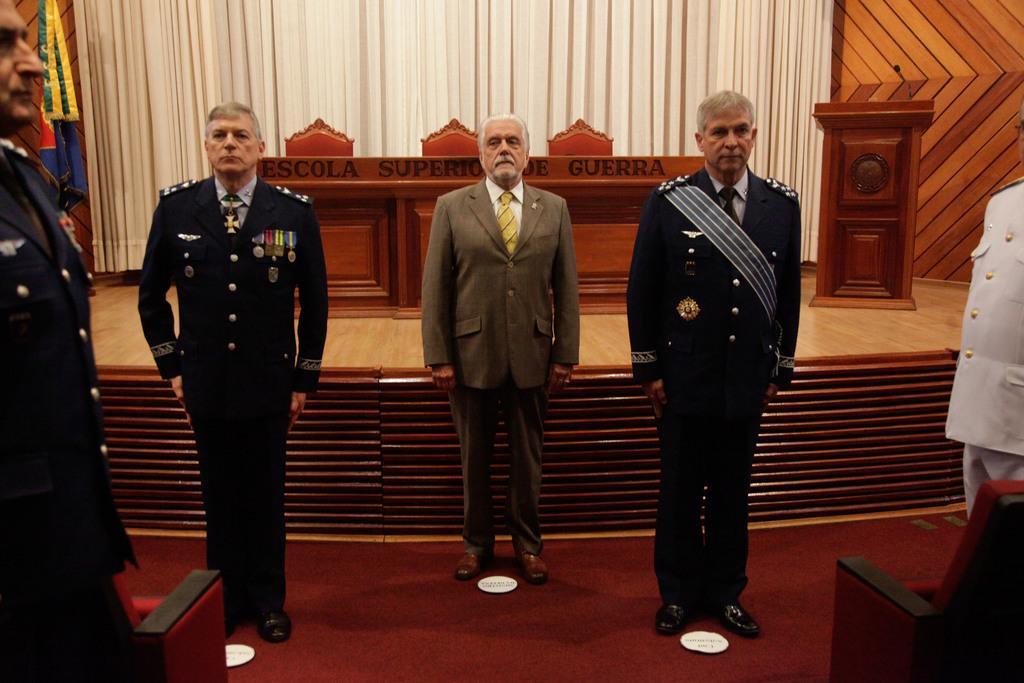How would you summarize this image in a sentence or two? In the image in the center we can see few people were standing in attention and we can see two chairs and white color objects. In the background we can see wood wall,table,chairs,microphone,wood stand,flag,curtain and few other objects. 